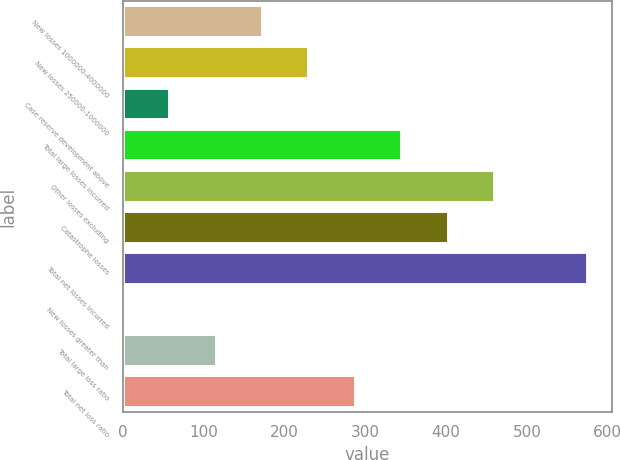Convert chart to OTSL. <chart><loc_0><loc_0><loc_500><loc_500><bar_chart><fcel>New losses 1000000-4000000<fcel>New losses 250000-1000000<fcel>Case reserve development above<fcel>Total large losses incurred<fcel>Other losses excluding<fcel>Catastrophe losses<fcel>Total net losses incurred<fcel>New losses greater than<fcel>Total large loss ratio<fcel>Total net loss ratio<nl><fcel>173.47<fcel>230.97<fcel>58.47<fcel>345.97<fcel>460.97<fcel>403.47<fcel>576<fcel>0.97<fcel>115.97<fcel>288.47<nl></chart> 